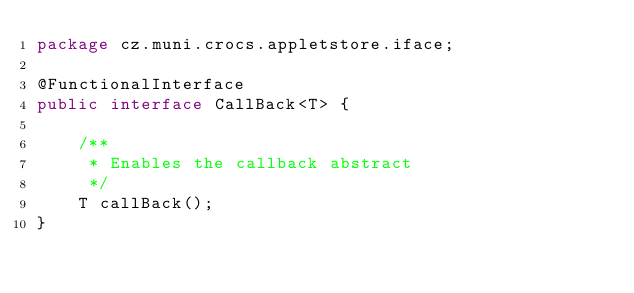<code> <loc_0><loc_0><loc_500><loc_500><_Java_>package cz.muni.crocs.appletstore.iface;

@FunctionalInterface
public interface CallBack<T> {

    /**
     * Enables the callback abstract
     */
    T callBack();
}
</code> 